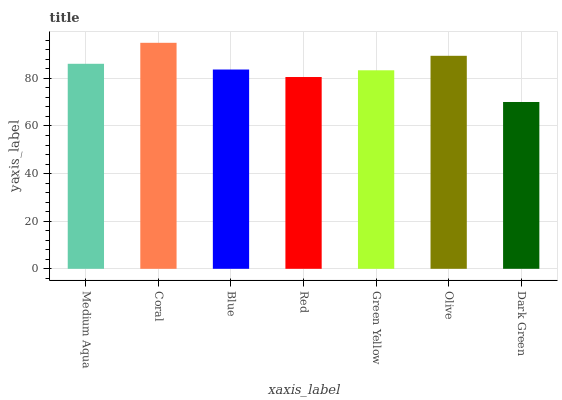Is Dark Green the minimum?
Answer yes or no. Yes. Is Coral the maximum?
Answer yes or no. Yes. Is Blue the minimum?
Answer yes or no. No. Is Blue the maximum?
Answer yes or no. No. Is Coral greater than Blue?
Answer yes or no. Yes. Is Blue less than Coral?
Answer yes or no. Yes. Is Blue greater than Coral?
Answer yes or no. No. Is Coral less than Blue?
Answer yes or no. No. Is Blue the high median?
Answer yes or no. Yes. Is Blue the low median?
Answer yes or no. Yes. Is Dark Green the high median?
Answer yes or no. No. Is Dark Green the low median?
Answer yes or no. No. 